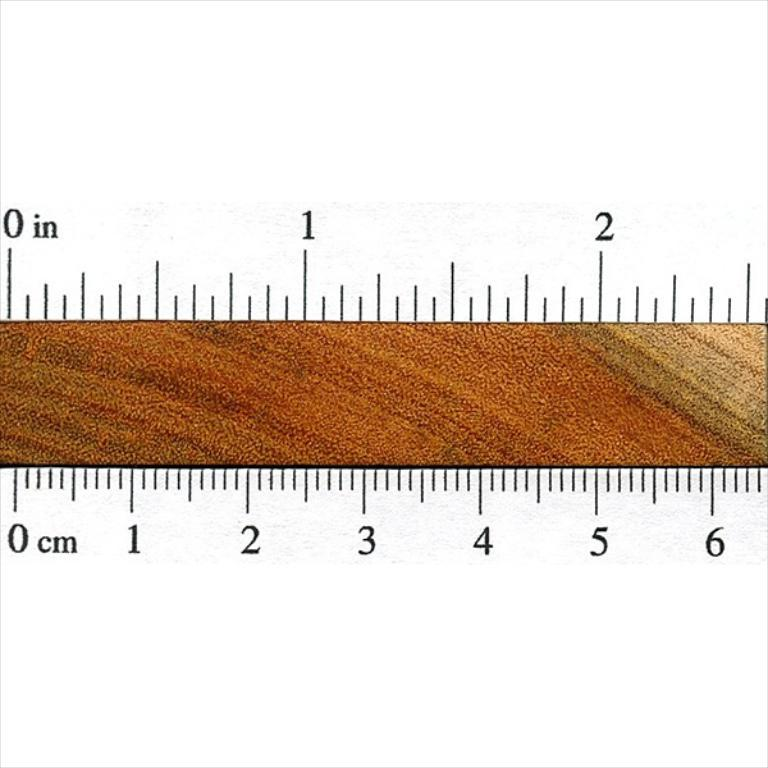<image>
Share a concise interpretation of the image provided. Lines around a ruler show measurements from 0 inches to a little over 2 1/2 inches. 